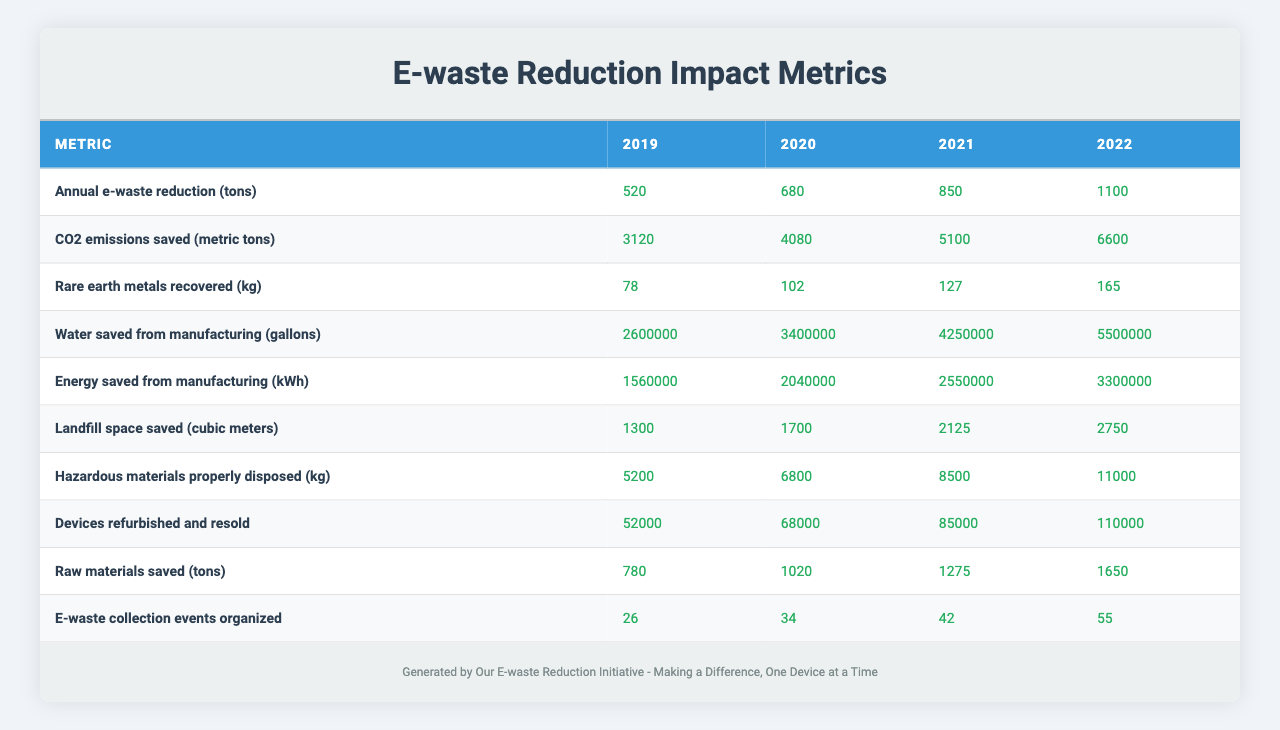What was the annual e-waste reduction in 2022? The table shows that the annual e-waste reduction in 2022 is listed under that metric in the year 2022 column. The value is 1100 tons.
Answer: 1100 tons How much CO2 emissions were saved from 2019 to 2022? To find the total CO2 emissions saved from 2019 to 2022, sum the values: 3120 + 4080 + 5100 + 6600 = 18900 metric tons.
Answer: 18900 metric tons What is the percentage increase in devices refurbished and resold from 2019 to 2022? The number of devices refurbished and resold in 2019 is 52000 and in 2022 is 110000. The increase is 110000 - 52000 = 58000. To calculate the percentage increase, (58000/52000) * 100 = 111.54%.
Answer: 111.54% Did the number of e-waste collection events increase every year from 2019 to 2022? By checking the column for the number of e-waste collection events for each year, you can see that it increased from 26 in 2019 to 55 in 2022, confirming that it did increase every year.
Answer: Yes What was the average annual reduction of e-waste from 2019 to 2022? To calculate the average annual reduction of e-waste, sum the values for each year: 520 + 680 + 850 + 1100 = 3150 tons. Then divide by the number of years, which is 4: 3150/4 = 787.5 tons.
Answer: 787.5 tons How much rare earth metals were recovered in total from 2019 to 2022? The total rare earth metals recovered is found by adding the values from each year: 78 + 102 + 127 + 165 = 472 kg.
Answer: 472 kg Was the water saved from manufacturing in 2021 greater than that saved in 2019? The water saved from manufacturing in 2021 is 4250000 gallons, while in 2019 it was 2600000 gallons. Since 4250000 is greater, the statement is true.
Answer: Yes What is the total energy saved from manufacturing from 2019 to 2022? Add the energy saved for each year: 1560000 + 2040000 + 2550000 + 3300000 = 9450000 kWh.
Answer: 9450000 kWh How much landfill space was saved in 2020 compared to 2022? The landfill space saved in 2020 was 1700 cubic meters and in 2022 it was 2750 cubic meters. The difference is 2750 - 1700 = 1050 cubic meters.
Answer: 1050 cubic meters Did the amount of hazardous materials disposed of increase from 2019 to 2022? Comparing the values from 2019 (5200 kg) to 2022 (11000 kg), it shows an increase, confirming that the disposal of hazardous materials increased.
Answer: Yes 